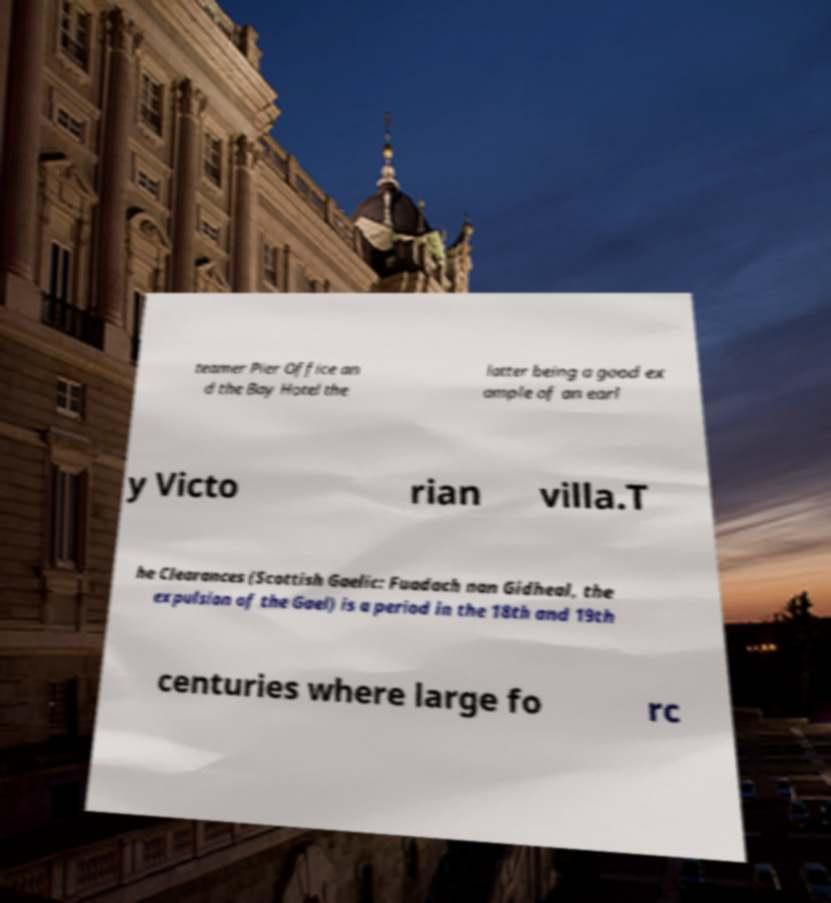I need the written content from this picture converted into text. Can you do that? teamer Pier Office an d the Bay Hotel the latter being a good ex ample of an earl y Victo rian villa.T he Clearances (Scottish Gaelic: Fuadach nan Gidheal, the expulsion of the Gael) is a period in the 18th and 19th centuries where large fo rc 